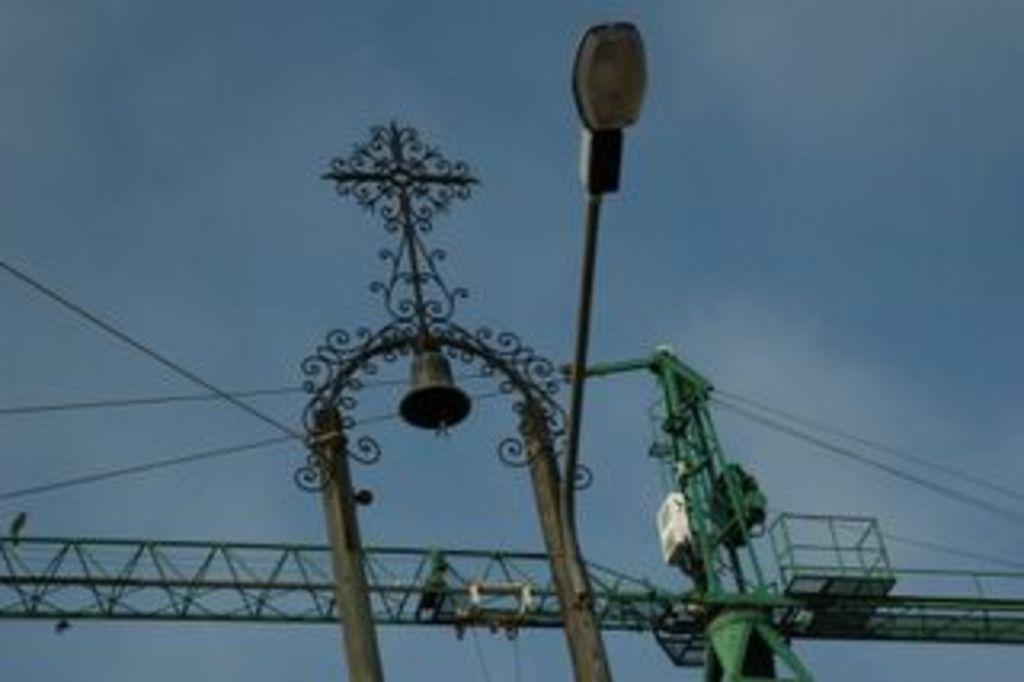What type of structure can be seen in the image? There is a lamp post in the image. What other object is present in the image? There is a bell in the image. What material is used for the rods visible in the image? Metal rods are visible in the image. What connects the various structures in the image? Cables are present in the image. What large machine can be seen in the image? There is a crane in the image. What type of brush is being used by the coach in the image? There is no brush or coach present in the image. 